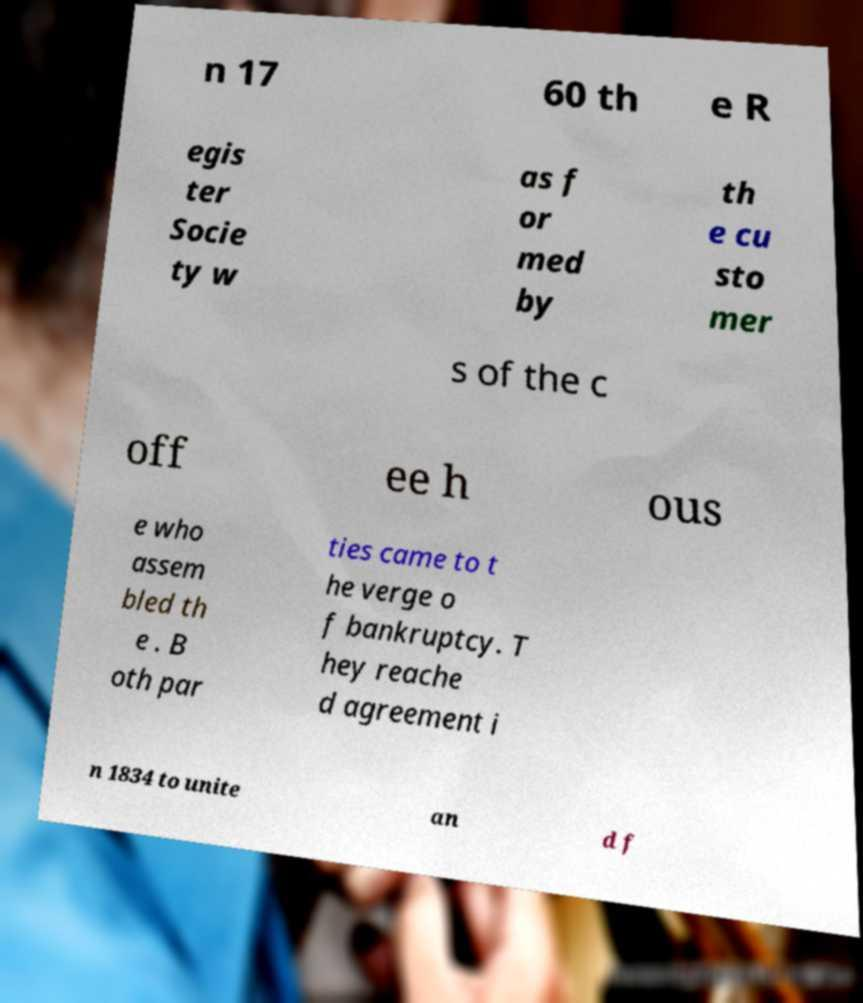There's text embedded in this image that I need extracted. Can you transcribe it verbatim? n 17 60 th e R egis ter Socie ty w as f or med by th e cu sto mer s of the c off ee h ous e who assem bled th e . B oth par ties came to t he verge o f bankruptcy. T hey reache d agreement i n 1834 to unite an d f 